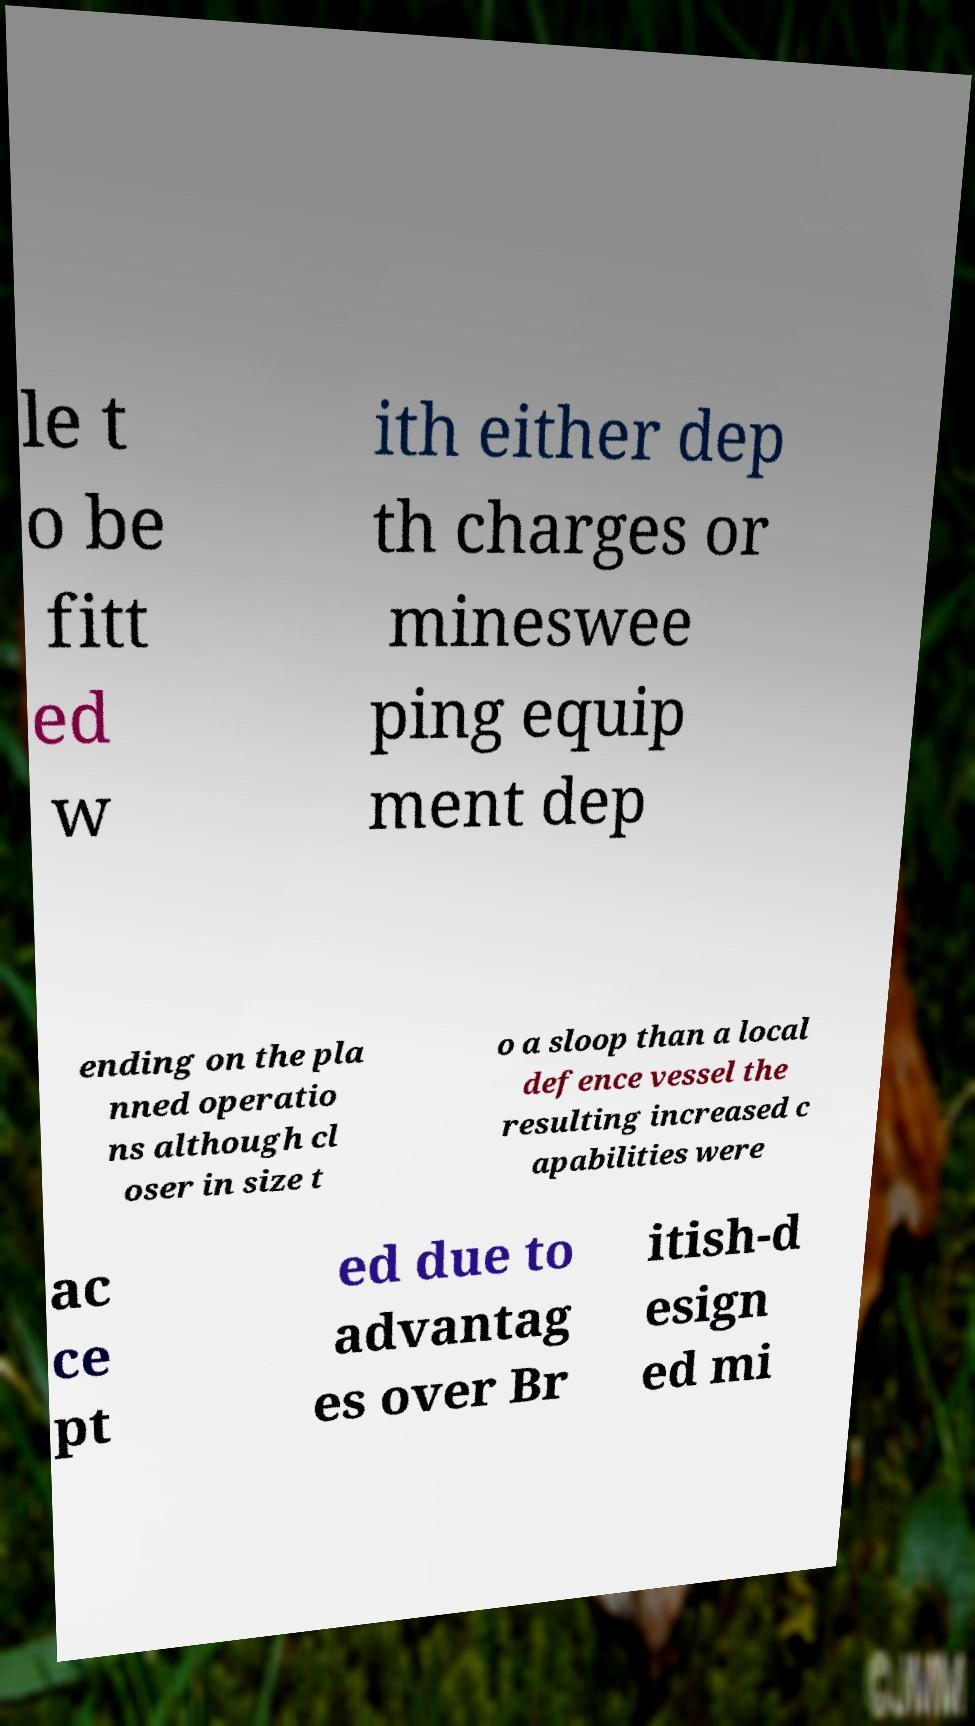Please identify and transcribe the text found in this image. le t o be fitt ed w ith either dep th charges or mineswee ping equip ment dep ending on the pla nned operatio ns although cl oser in size t o a sloop than a local defence vessel the resulting increased c apabilities were ac ce pt ed due to advantag es over Br itish-d esign ed mi 